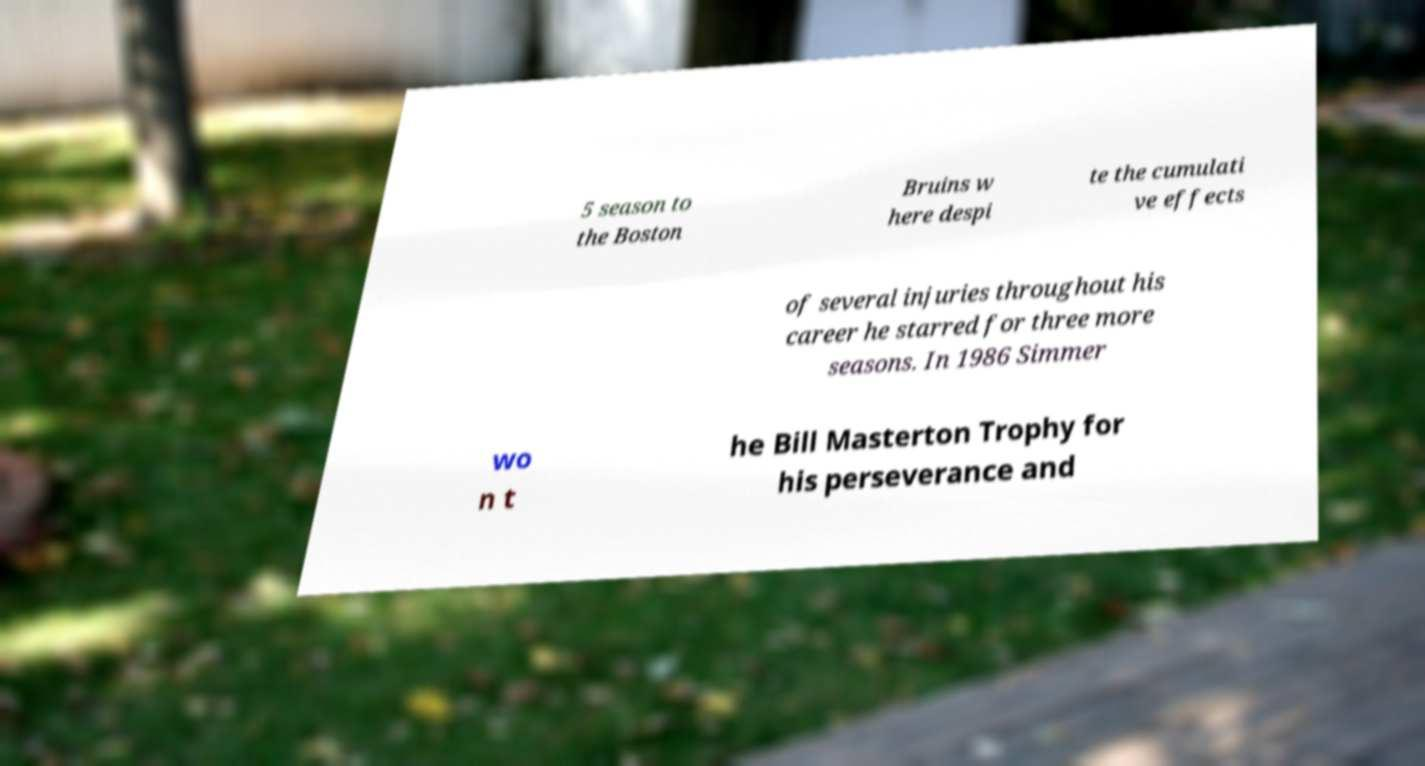Can you accurately transcribe the text from the provided image for me? 5 season to the Boston Bruins w here despi te the cumulati ve effects of several injuries throughout his career he starred for three more seasons. In 1986 Simmer wo n t he Bill Masterton Trophy for his perseverance and 